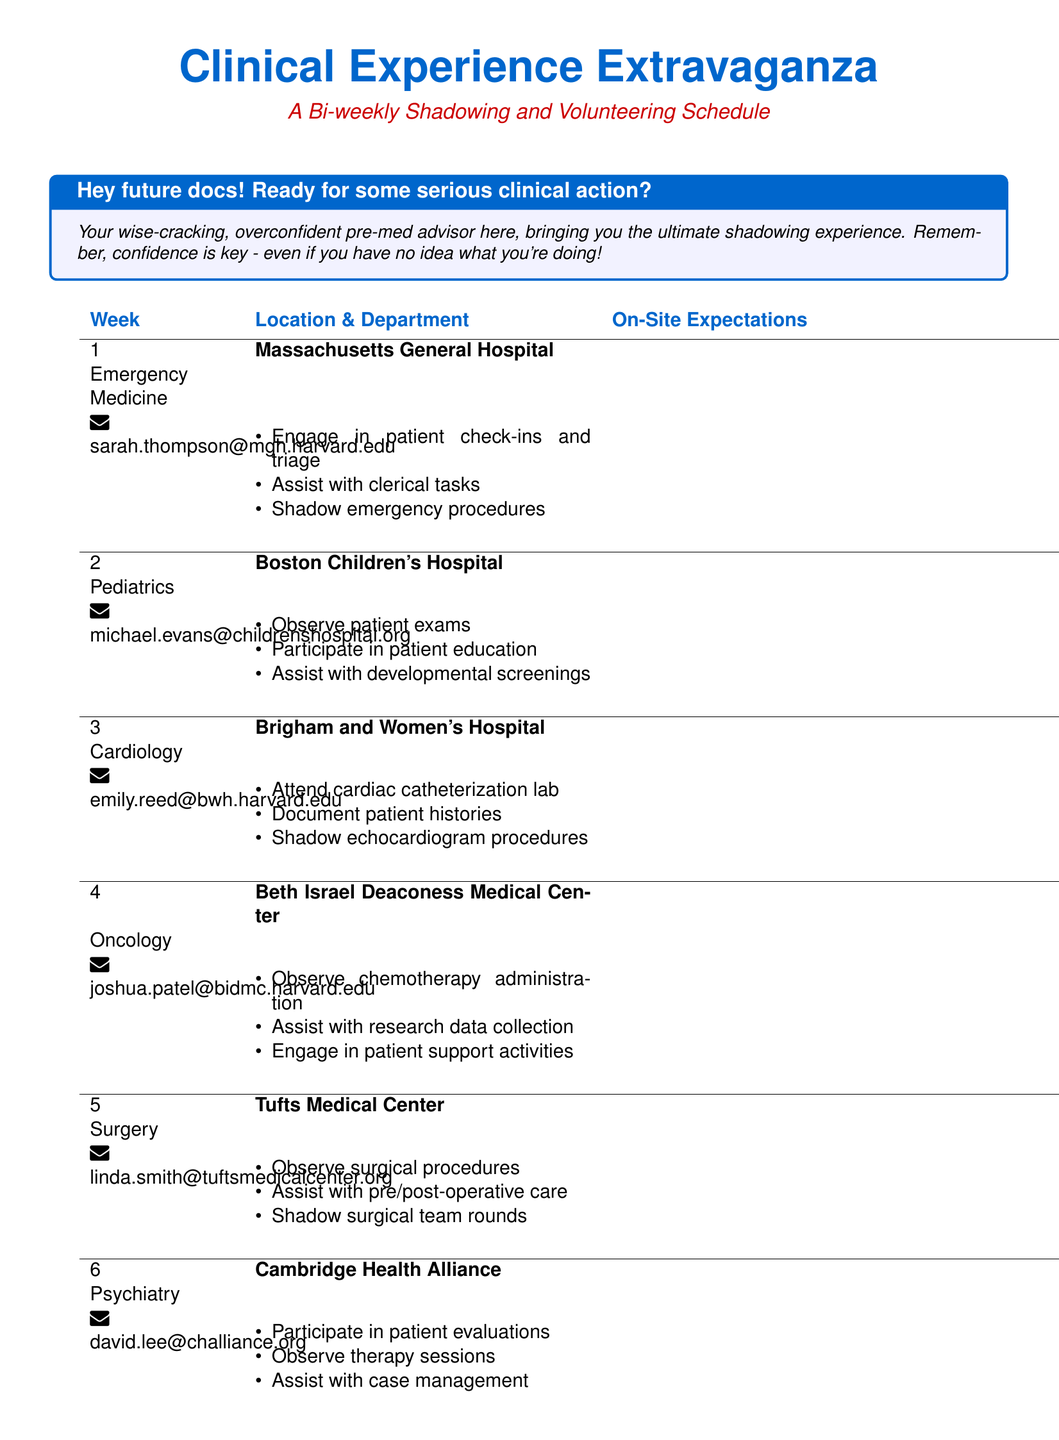What is the email contact for emergency medicine? The document lists Sarah Thompson's email for emergency medicine as sarah.thompson@mgh.harvard.edu.
Answer: sarah.thompson@mgh.harvard.edu Which department is associated with Tufts Medical Center? The document specifies the department of Surgery for Tufts Medical Center.
Answer: Surgery How many weeks does the Clinical Experience Extravaganza span? The document indicates there are 6 weeks in the schedule.
Answer: 6 What should participants observe at Boston Children's Hospital? Participants are expected to observe patient exams at Boston Children's Hospital.
Answer: patient exams Which hospital features cardiology in its schedule? The document states Brigham and Women's Hospital has cardiology in its schedule.
Answer: Brigham and Women's Hospital What is an on-site expectation for oncology at Beth Israel Deaconess Medical Center? The document lists observing chemotherapy administration as an expectation for oncology.
Answer: Observe chemotherapy administration Who is the contact person for psychiatry at Cambridge Health Alliance? The document names David Lee as the contact person for psychiatry.
Answer: David Lee What type of activities should participants engage in during their oncology rotation? The document mentions engaging in patient support activities for oncology.
Answer: patient support activities 